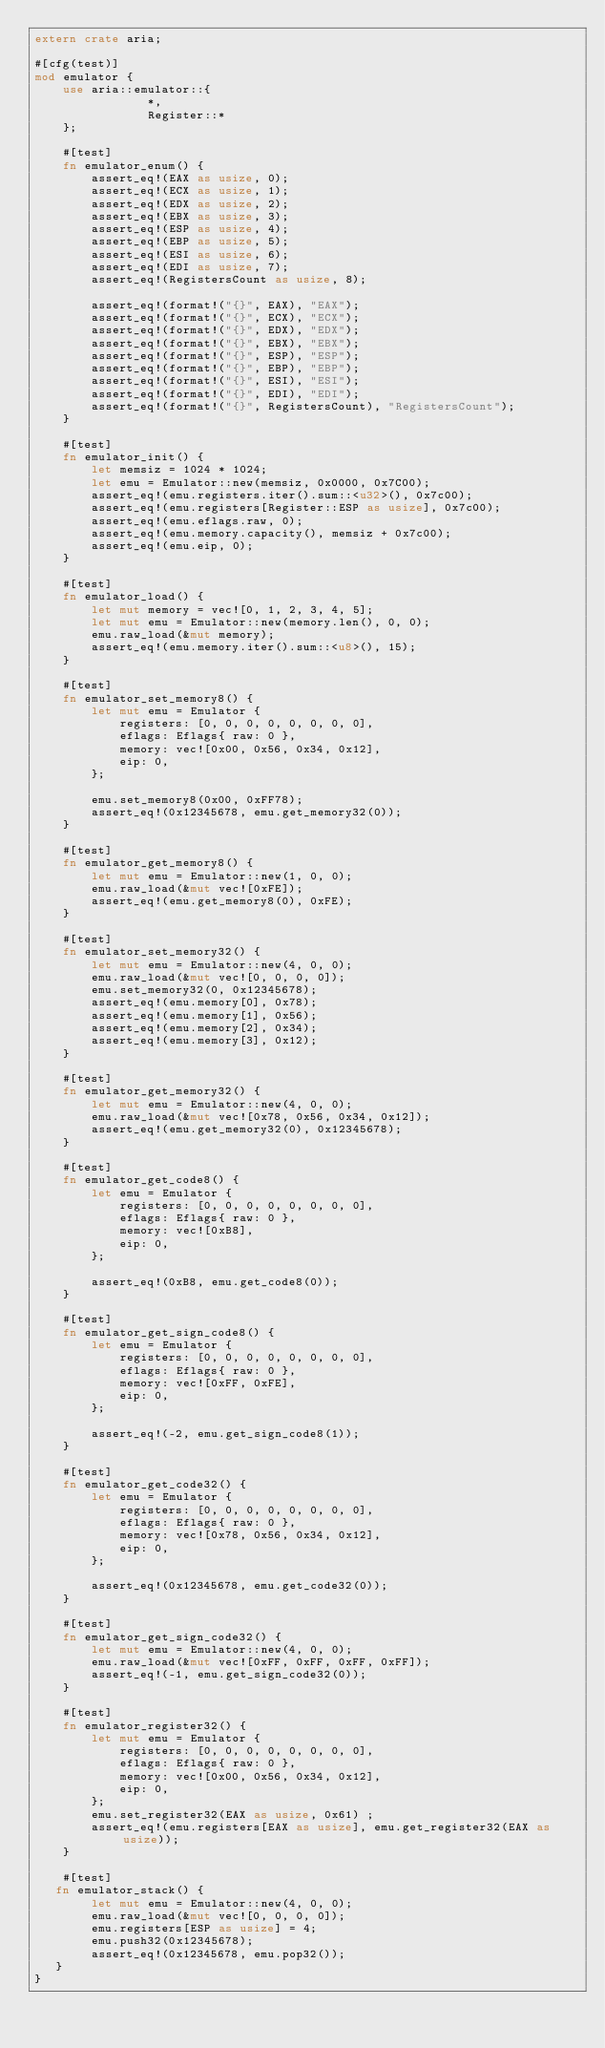<code> <loc_0><loc_0><loc_500><loc_500><_Rust_>extern crate aria;

#[cfg(test)]
mod emulator {
    use aria::emulator::{
                *,
                Register::*
    };
    
    #[test]
    fn emulator_enum() {
        assert_eq!(EAX as usize, 0);
        assert_eq!(ECX as usize, 1);
        assert_eq!(EDX as usize, 2);
        assert_eq!(EBX as usize, 3);
        assert_eq!(ESP as usize, 4);
        assert_eq!(EBP as usize, 5);
        assert_eq!(ESI as usize, 6);
        assert_eq!(EDI as usize, 7);
        assert_eq!(RegistersCount as usize, 8);
    
        assert_eq!(format!("{}", EAX), "EAX");
        assert_eq!(format!("{}", ECX), "ECX");
        assert_eq!(format!("{}", EDX), "EDX");
        assert_eq!(format!("{}", EBX), "EBX");
        assert_eq!(format!("{}", ESP), "ESP");
        assert_eq!(format!("{}", EBP), "EBP");
        assert_eq!(format!("{}", ESI), "ESI");
        assert_eq!(format!("{}", EDI), "EDI");
        assert_eq!(format!("{}", RegistersCount), "RegistersCount");
    }
    
    #[test]
    fn emulator_init() {
        let memsiz = 1024 * 1024;
        let emu = Emulator::new(memsiz, 0x0000, 0x7C00);
        assert_eq!(emu.registers.iter().sum::<u32>(), 0x7c00);
        assert_eq!(emu.registers[Register::ESP as usize], 0x7c00);
        assert_eq!(emu.eflags.raw, 0);
        assert_eq!(emu.memory.capacity(), memsiz + 0x7c00);
        assert_eq!(emu.eip, 0);
    }

    #[test]
    fn emulator_load() {
        let mut memory = vec![0, 1, 2, 3, 4, 5];
        let mut emu = Emulator::new(memory.len(), 0, 0);
        emu.raw_load(&mut memory);
        assert_eq!(emu.memory.iter().sum::<u8>(), 15);
    }
    
    #[test]
    fn emulator_set_memory8() {
        let mut emu = Emulator {
            registers: [0, 0, 0, 0, 0, 0, 0, 0],
            eflags: Eflags{ raw: 0 },
            memory: vec![0x00, 0x56, 0x34, 0x12],
            eip: 0,
        };
    
        emu.set_memory8(0x00, 0xFF78);
        assert_eq!(0x12345678, emu.get_memory32(0));
    }

    #[test]
    fn emulator_get_memory8() {
        let mut emu = Emulator::new(1, 0, 0);
        emu.raw_load(&mut vec![0xFE]);
        assert_eq!(emu.get_memory8(0), 0xFE);
    }

    #[test]
    fn emulator_set_memory32() {
        let mut emu = Emulator::new(4, 0, 0);
        emu.raw_load(&mut vec![0, 0, 0, 0]);
        emu.set_memory32(0, 0x12345678);
        assert_eq!(emu.memory[0], 0x78);
        assert_eq!(emu.memory[1], 0x56);
        assert_eq!(emu.memory[2], 0x34);
        assert_eq!(emu.memory[3], 0x12);
    }

    #[test]
    fn emulator_get_memory32() {
        let mut emu = Emulator::new(4, 0, 0);
        emu.raw_load(&mut vec![0x78, 0x56, 0x34, 0x12]);
        assert_eq!(emu.get_memory32(0), 0x12345678);
    }

    #[test]
    fn emulator_get_code8() {
        let emu = Emulator {
            registers: [0, 0, 0, 0, 0, 0, 0, 0],
            eflags: Eflags{ raw: 0 },
            memory: vec![0xB8],
            eip: 0,
        };
    
        assert_eq!(0xB8, emu.get_code8(0));
    }
    
    #[test]
    fn emulator_get_sign_code8() {
        let emu = Emulator {
            registers: [0, 0, 0, 0, 0, 0, 0, 0],
            eflags: Eflags{ raw: 0 },
            memory: vec![0xFF, 0xFE],
            eip: 0,
        };
    
        assert_eq!(-2, emu.get_sign_code8(1));
    }
    
    #[test]
    fn emulator_get_code32() {
        let emu = Emulator {
            registers: [0, 0, 0, 0, 0, 0, 0, 0],
            eflags: Eflags{ raw: 0 },
            memory: vec![0x78, 0x56, 0x34, 0x12],
            eip: 0,
        };
    
        assert_eq!(0x12345678, emu.get_code32(0));
    }

    #[test]
    fn emulator_get_sign_code32() {
        let mut emu = Emulator::new(4, 0, 0);
        emu.raw_load(&mut vec![0xFF, 0xFF, 0xFF, 0xFF]);
        assert_eq!(-1, emu.get_sign_code32(0));
    }
    
    #[test]
    fn emulator_register32() {
        let mut emu = Emulator {
            registers: [0, 0, 0, 0, 0, 0, 0, 0],
            eflags: Eflags{ raw: 0 },
            memory: vec![0x00, 0x56, 0x34, 0x12],
            eip: 0,
        };
        emu.set_register32(EAX as usize, 0x61) ;
        assert_eq!(emu.registers[EAX as usize], emu.get_register32(EAX as usize));
    }

    #[test]
   fn emulator_stack() {
        let mut emu = Emulator::new(4, 0, 0);
        emu.raw_load(&mut vec![0, 0, 0, 0]);
        emu.registers[ESP as usize] = 4;
        emu.push32(0x12345678);
        assert_eq!(0x12345678, emu.pop32());
   }
}
</code> 